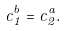Convert formula to latex. <formula><loc_0><loc_0><loc_500><loc_500>c _ { 1 } ^ { b } = c _ { 2 } ^ { a } .</formula> 